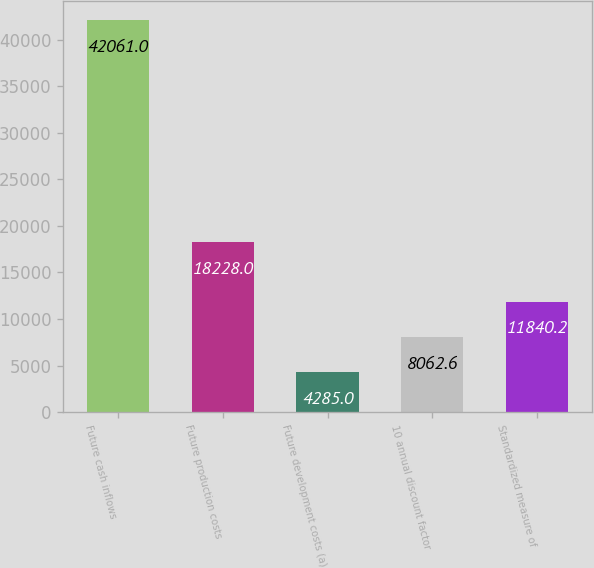Convert chart. <chart><loc_0><loc_0><loc_500><loc_500><bar_chart><fcel>Future cash inflows<fcel>Future production costs<fcel>Future development costs (a)<fcel>10 annual discount factor<fcel>Standardized measure of<nl><fcel>42061<fcel>18228<fcel>4285<fcel>8062.6<fcel>11840.2<nl></chart> 